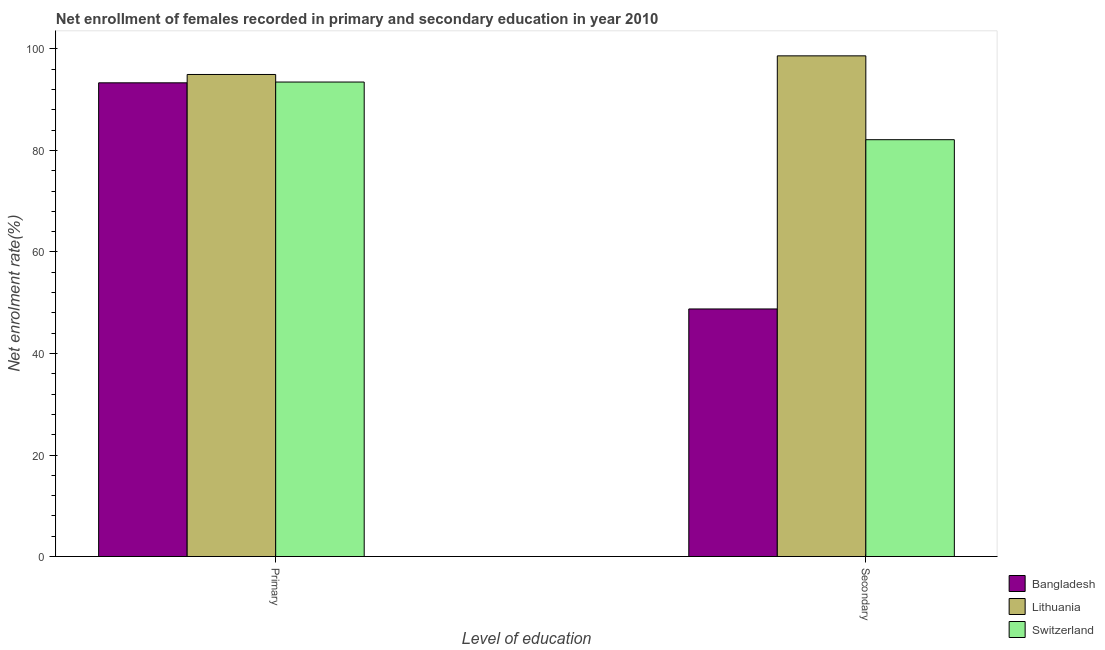How many groups of bars are there?
Keep it short and to the point. 2. How many bars are there on the 2nd tick from the left?
Offer a very short reply. 3. How many bars are there on the 1st tick from the right?
Keep it short and to the point. 3. What is the label of the 2nd group of bars from the left?
Make the answer very short. Secondary. What is the enrollment rate in secondary education in Lithuania?
Offer a terse response. 98.64. Across all countries, what is the maximum enrollment rate in primary education?
Provide a short and direct response. 94.97. Across all countries, what is the minimum enrollment rate in secondary education?
Your answer should be compact. 48.78. In which country was the enrollment rate in primary education maximum?
Your response must be concise. Lithuania. What is the total enrollment rate in primary education in the graph?
Ensure brevity in your answer.  281.78. What is the difference between the enrollment rate in primary education in Bangladesh and that in Lithuania?
Your answer should be compact. -1.65. What is the difference between the enrollment rate in secondary education in Lithuania and the enrollment rate in primary education in Bangladesh?
Provide a short and direct response. 5.31. What is the average enrollment rate in primary education per country?
Ensure brevity in your answer.  93.93. What is the difference between the enrollment rate in primary education and enrollment rate in secondary education in Lithuania?
Give a very brief answer. -3.67. What is the ratio of the enrollment rate in primary education in Bangladesh to that in Switzerland?
Your answer should be compact. 1. Is the enrollment rate in secondary education in Switzerland less than that in Bangladesh?
Your answer should be very brief. No. In how many countries, is the enrollment rate in secondary education greater than the average enrollment rate in secondary education taken over all countries?
Ensure brevity in your answer.  2. What does the 1st bar from the left in Secondary represents?
Make the answer very short. Bangladesh. What does the 3rd bar from the right in Secondary represents?
Your answer should be very brief. Bangladesh. How many countries are there in the graph?
Your response must be concise. 3. What is the difference between two consecutive major ticks on the Y-axis?
Provide a succinct answer. 20. Are the values on the major ticks of Y-axis written in scientific E-notation?
Make the answer very short. No. Does the graph contain any zero values?
Provide a succinct answer. No. Does the graph contain grids?
Keep it short and to the point. No. How are the legend labels stacked?
Make the answer very short. Vertical. What is the title of the graph?
Offer a very short reply. Net enrollment of females recorded in primary and secondary education in year 2010. Does "Lebanon" appear as one of the legend labels in the graph?
Keep it short and to the point. No. What is the label or title of the X-axis?
Provide a short and direct response. Level of education. What is the label or title of the Y-axis?
Offer a very short reply. Net enrolment rate(%). What is the Net enrolment rate(%) in Bangladesh in Primary?
Make the answer very short. 93.33. What is the Net enrolment rate(%) of Lithuania in Primary?
Offer a very short reply. 94.97. What is the Net enrolment rate(%) in Switzerland in Primary?
Your answer should be compact. 93.48. What is the Net enrolment rate(%) of Bangladesh in Secondary?
Provide a short and direct response. 48.78. What is the Net enrolment rate(%) of Lithuania in Secondary?
Offer a very short reply. 98.64. What is the Net enrolment rate(%) in Switzerland in Secondary?
Offer a terse response. 82.12. Across all Level of education, what is the maximum Net enrolment rate(%) in Bangladesh?
Ensure brevity in your answer.  93.33. Across all Level of education, what is the maximum Net enrolment rate(%) in Lithuania?
Ensure brevity in your answer.  98.64. Across all Level of education, what is the maximum Net enrolment rate(%) in Switzerland?
Give a very brief answer. 93.48. Across all Level of education, what is the minimum Net enrolment rate(%) in Bangladesh?
Ensure brevity in your answer.  48.78. Across all Level of education, what is the minimum Net enrolment rate(%) in Lithuania?
Ensure brevity in your answer.  94.97. Across all Level of education, what is the minimum Net enrolment rate(%) in Switzerland?
Make the answer very short. 82.12. What is the total Net enrolment rate(%) in Bangladesh in the graph?
Your answer should be compact. 142.1. What is the total Net enrolment rate(%) of Lithuania in the graph?
Ensure brevity in your answer.  193.61. What is the total Net enrolment rate(%) of Switzerland in the graph?
Keep it short and to the point. 175.61. What is the difference between the Net enrolment rate(%) of Bangladesh in Primary and that in Secondary?
Your answer should be compact. 44.55. What is the difference between the Net enrolment rate(%) in Lithuania in Primary and that in Secondary?
Keep it short and to the point. -3.67. What is the difference between the Net enrolment rate(%) in Switzerland in Primary and that in Secondary?
Your answer should be very brief. 11.36. What is the difference between the Net enrolment rate(%) in Bangladesh in Primary and the Net enrolment rate(%) in Lithuania in Secondary?
Keep it short and to the point. -5.31. What is the difference between the Net enrolment rate(%) in Bangladesh in Primary and the Net enrolment rate(%) in Switzerland in Secondary?
Give a very brief answer. 11.2. What is the difference between the Net enrolment rate(%) of Lithuania in Primary and the Net enrolment rate(%) of Switzerland in Secondary?
Provide a succinct answer. 12.85. What is the average Net enrolment rate(%) in Bangladesh per Level of education?
Your answer should be very brief. 71.05. What is the average Net enrolment rate(%) in Lithuania per Level of education?
Your response must be concise. 96.81. What is the average Net enrolment rate(%) of Switzerland per Level of education?
Offer a very short reply. 87.8. What is the difference between the Net enrolment rate(%) of Bangladesh and Net enrolment rate(%) of Lithuania in Primary?
Offer a very short reply. -1.65. What is the difference between the Net enrolment rate(%) in Bangladesh and Net enrolment rate(%) in Switzerland in Primary?
Provide a short and direct response. -0.16. What is the difference between the Net enrolment rate(%) of Lithuania and Net enrolment rate(%) of Switzerland in Primary?
Make the answer very short. 1.49. What is the difference between the Net enrolment rate(%) of Bangladesh and Net enrolment rate(%) of Lithuania in Secondary?
Provide a short and direct response. -49.86. What is the difference between the Net enrolment rate(%) in Bangladesh and Net enrolment rate(%) in Switzerland in Secondary?
Provide a succinct answer. -33.35. What is the difference between the Net enrolment rate(%) in Lithuania and Net enrolment rate(%) in Switzerland in Secondary?
Your answer should be compact. 16.52. What is the ratio of the Net enrolment rate(%) in Bangladesh in Primary to that in Secondary?
Give a very brief answer. 1.91. What is the ratio of the Net enrolment rate(%) in Lithuania in Primary to that in Secondary?
Provide a short and direct response. 0.96. What is the ratio of the Net enrolment rate(%) in Switzerland in Primary to that in Secondary?
Keep it short and to the point. 1.14. What is the difference between the highest and the second highest Net enrolment rate(%) of Bangladesh?
Provide a succinct answer. 44.55. What is the difference between the highest and the second highest Net enrolment rate(%) in Lithuania?
Your answer should be compact. 3.67. What is the difference between the highest and the second highest Net enrolment rate(%) of Switzerland?
Give a very brief answer. 11.36. What is the difference between the highest and the lowest Net enrolment rate(%) in Bangladesh?
Provide a short and direct response. 44.55. What is the difference between the highest and the lowest Net enrolment rate(%) in Lithuania?
Offer a terse response. 3.67. What is the difference between the highest and the lowest Net enrolment rate(%) in Switzerland?
Provide a succinct answer. 11.36. 